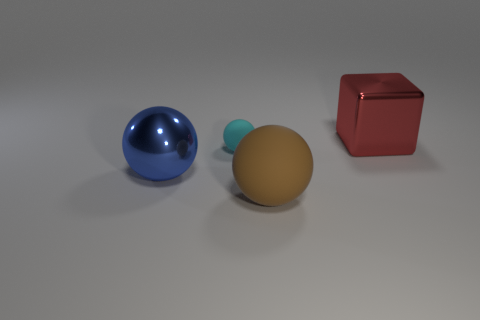Add 1 big red cylinders. How many objects exist? 5 Subtract all cubes. How many objects are left? 3 Subtract all cyan objects. Subtract all metallic spheres. How many objects are left? 2 Add 4 blue metallic spheres. How many blue metallic spheres are left? 5 Add 1 gray rubber spheres. How many gray rubber spheres exist? 1 Subtract 0 red spheres. How many objects are left? 4 